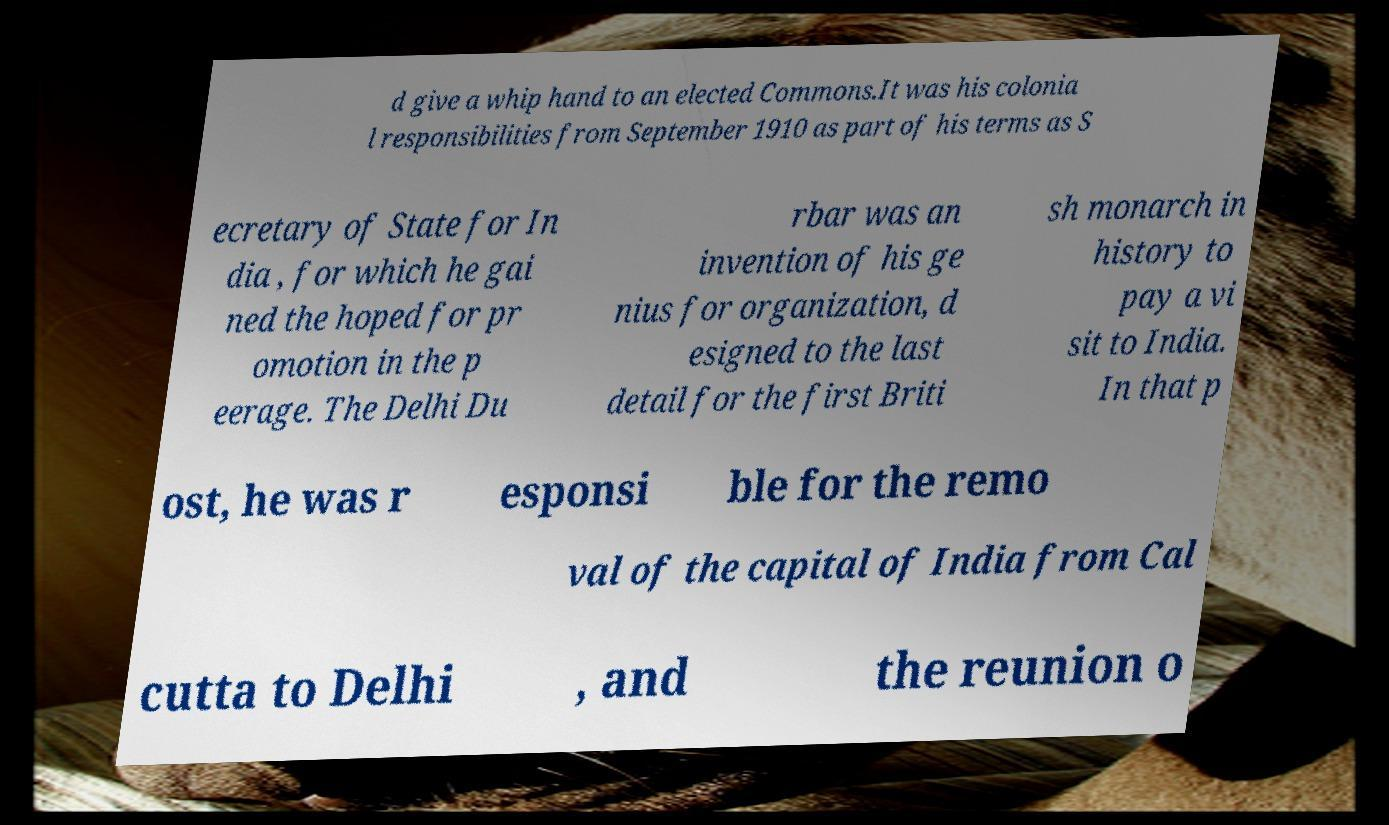Can you read and provide the text displayed in the image?This photo seems to have some interesting text. Can you extract and type it out for me? d give a whip hand to an elected Commons.It was his colonia l responsibilities from September 1910 as part of his terms as S ecretary of State for In dia , for which he gai ned the hoped for pr omotion in the p eerage. The Delhi Du rbar was an invention of his ge nius for organization, d esigned to the last detail for the first Briti sh monarch in history to pay a vi sit to India. In that p ost, he was r esponsi ble for the remo val of the capital of India from Cal cutta to Delhi , and the reunion o 